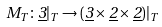Convert formula to latex. <formula><loc_0><loc_0><loc_500><loc_500>M _ { T } \colon \underline { 3 } | _ { T } \rightarrow ( \underline { 3 } \times \underline { 2 } \times \underline { 2 } ) | _ { T }</formula> 